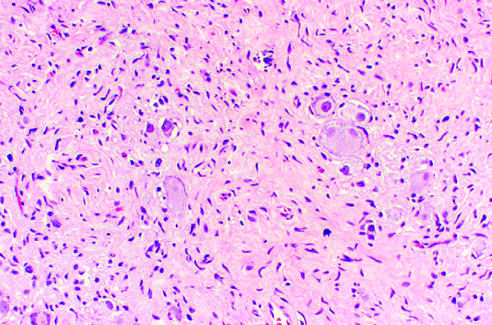re ganglioneuromas characterized by clusters of large ganglion cells with vesicular nuclei and abundant eosinophilic cytoplasm (arrow)?
Answer the question using a single word or phrase. Yes 